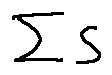<formula> <loc_0><loc_0><loc_500><loc_500>\sum S</formula> 